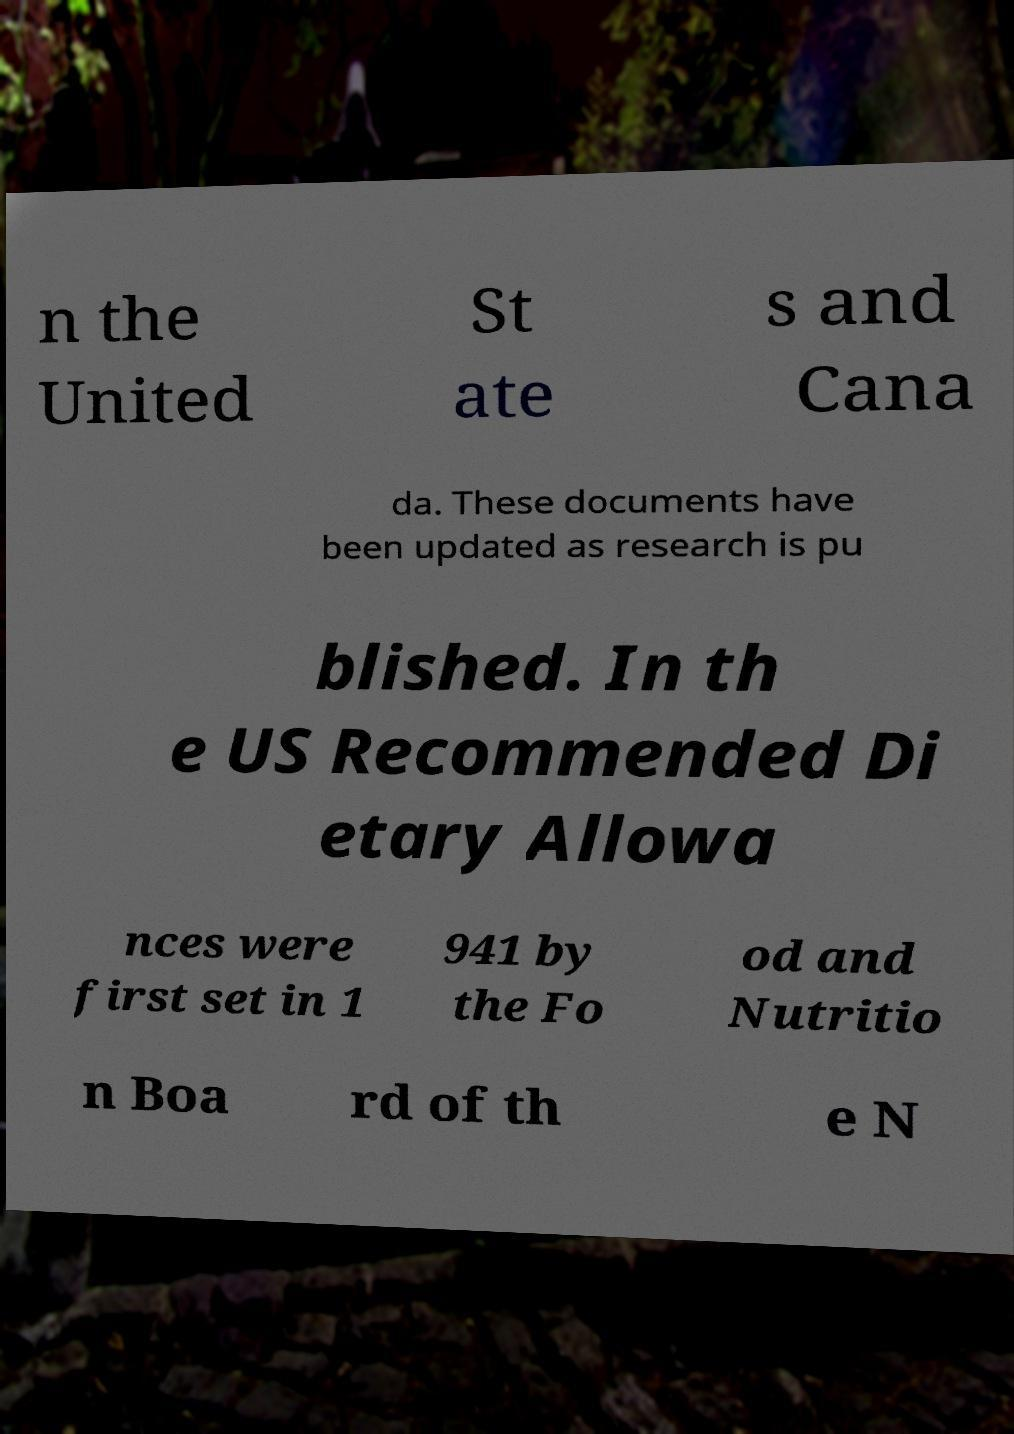What messages or text are displayed in this image? I need them in a readable, typed format. n the United St ate s and Cana da. These documents have been updated as research is pu blished. In th e US Recommended Di etary Allowa nces were first set in 1 941 by the Fo od and Nutritio n Boa rd of th e N 